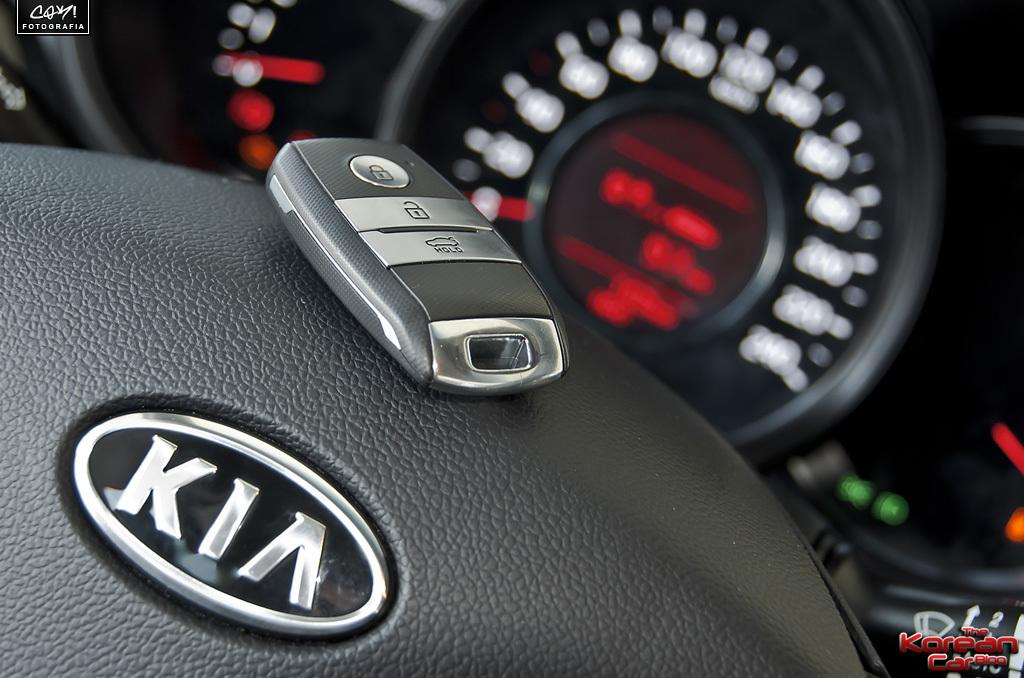What type of space is depicted in the image? The image shows the interior of a vehicle. Can you identify any specific objects within the vehicle? Yes, there is a remote-key on the steering wheel in the image. Where is the crate of apples located in the image? There is no crate of apples present in the image; it only shows the interior of a vehicle with a remote-key on the steering wheel. 